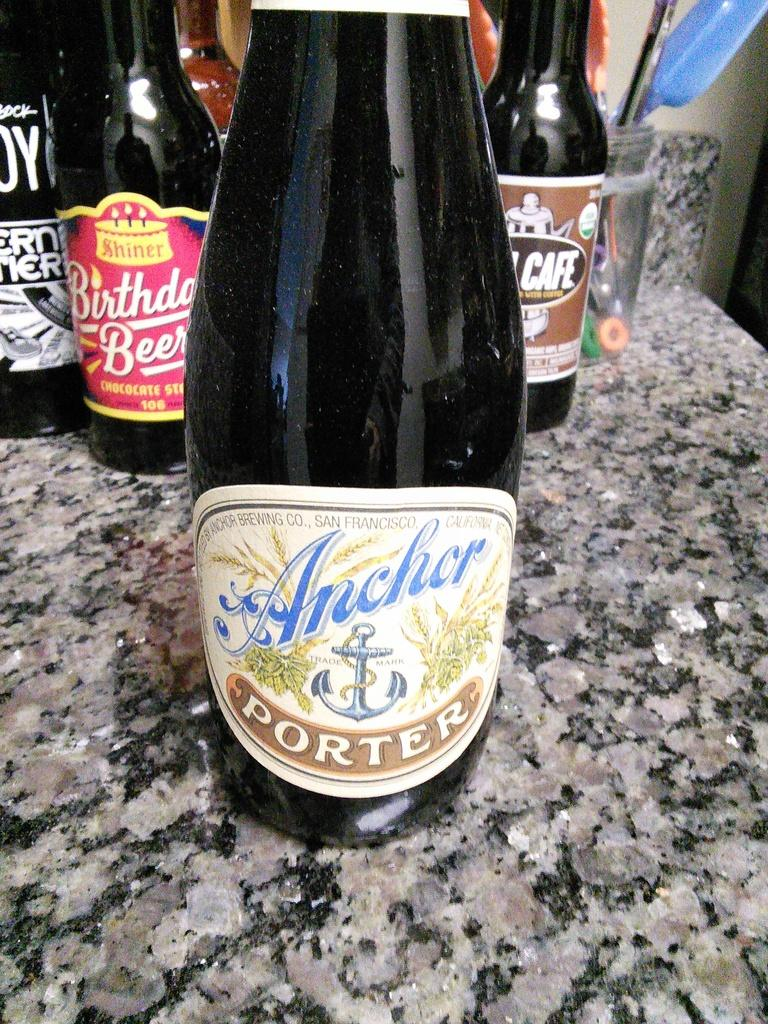<image>
Relay a brief, clear account of the picture shown. a bottle of ancher porter beer in front of other bottles 